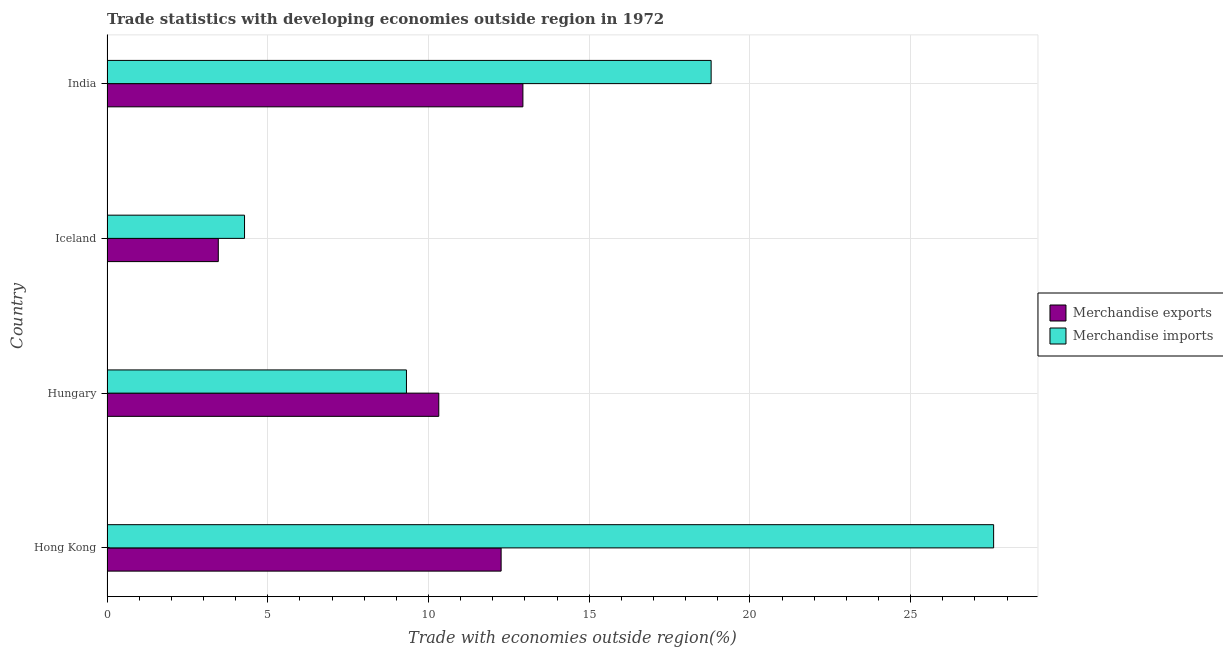How many groups of bars are there?
Keep it short and to the point. 4. Are the number of bars per tick equal to the number of legend labels?
Your answer should be very brief. Yes. Are the number of bars on each tick of the Y-axis equal?
Your response must be concise. Yes. How many bars are there on the 1st tick from the bottom?
Keep it short and to the point. 2. What is the label of the 1st group of bars from the top?
Your response must be concise. India. What is the merchandise exports in India?
Ensure brevity in your answer.  12.94. Across all countries, what is the maximum merchandise exports?
Make the answer very short. 12.94. Across all countries, what is the minimum merchandise imports?
Give a very brief answer. 4.28. In which country was the merchandise imports maximum?
Your answer should be very brief. Hong Kong. What is the total merchandise imports in the graph?
Give a very brief answer. 59.97. What is the difference between the merchandise exports in Hungary and that in Iceland?
Offer a terse response. 6.86. What is the difference between the merchandise exports in Hong Kong and the merchandise imports in India?
Keep it short and to the point. -6.53. What is the average merchandise exports per country?
Keep it short and to the point. 9.74. What is the difference between the merchandise imports and merchandise exports in India?
Give a very brief answer. 5.86. What is the ratio of the merchandise exports in Hong Kong to that in Hungary?
Give a very brief answer. 1.19. What is the difference between the highest and the second highest merchandise exports?
Offer a terse response. 0.68. What is the difference between the highest and the lowest merchandise exports?
Give a very brief answer. 9.48. How many bars are there?
Ensure brevity in your answer.  8. Are all the bars in the graph horizontal?
Provide a succinct answer. Yes. How many countries are there in the graph?
Ensure brevity in your answer.  4. Are the values on the major ticks of X-axis written in scientific E-notation?
Provide a short and direct response. No. Where does the legend appear in the graph?
Give a very brief answer. Center right. How many legend labels are there?
Your response must be concise. 2. How are the legend labels stacked?
Your response must be concise. Vertical. What is the title of the graph?
Your answer should be compact. Trade statistics with developing economies outside region in 1972. Does "Male entrants" appear as one of the legend labels in the graph?
Provide a succinct answer. No. What is the label or title of the X-axis?
Offer a very short reply. Trade with economies outside region(%). What is the Trade with economies outside region(%) of Merchandise exports in Hong Kong?
Make the answer very short. 12.26. What is the Trade with economies outside region(%) in Merchandise imports in Hong Kong?
Keep it short and to the point. 27.58. What is the Trade with economies outside region(%) in Merchandise exports in Hungary?
Provide a succinct answer. 10.32. What is the Trade with economies outside region(%) in Merchandise imports in Hungary?
Give a very brief answer. 9.31. What is the Trade with economies outside region(%) in Merchandise exports in Iceland?
Offer a terse response. 3.46. What is the Trade with economies outside region(%) in Merchandise imports in Iceland?
Your answer should be compact. 4.28. What is the Trade with economies outside region(%) of Merchandise exports in India?
Provide a succinct answer. 12.94. What is the Trade with economies outside region(%) of Merchandise imports in India?
Provide a succinct answer. 18.79. Across all countries, what is the maximum Trade with economies outside region(%) in Merchandise exports?
Ensure brevity in your answer.  12.94. Across all countries, what is the maximum Trade with economies outside region(%) in Merchandise imports?
Provide a short and direct response. 27.58. Across all countries, what is the minimum Trade with economies outside region(%) of Merchandise exports?
Offer a terse response. 3.46. Across all countries, what is the minimum Trade with economies outside region(%) in Merchandise imports?
Ensure brevity in your answer.  4.28. What is the total Trade with economies outside region(%) of Merchandise exports in the graph?
Your answer should be very brief. 38.98. What is the total Trade with economies outside region(%) in Merchandise imports in the graph?
Provide a succinct answer. 59.97. What is the difference between the Trade with economies outside region(%) of Merchandise exports in Hong Kong and that in Hungary?
Your answer should be very brief. 1.94. What is the difference between the Trade with economies outside region(%) in Merchandise imports in Hong Kong and that in Hungary?
Provide a succinct answer. 18.27. What is the difference between the Trade with economies outside region(%) in Merchandise exports in Hong Kong and that in Iceland?
Offer a very short reply. 8.8. What is the difference between the Trade with economies outside region(%) of Merchandise imports in Hong Kong and that in Iceland?
Keep it short and to the point. 23.3. What is the difference between the Trade with economies outside region(%) of Merchandise exports in Hong Kong and that in India?
Ensure brevity in your answer.  -0.68. What is the difference between the Trade with economies outside region(%) of Merchandise imports in Hong Kong and that in India?
Give a very brief answer. 8.79. What is the difference between the Trade with economies outside region(%) of Merchandise exports in Hungary and that in Iceland?
Your response must be concise. 6.86. What is the difference between the Trade with economies outside region(%) of Merchandise imports in Hungary and that in Iceland?
Make the answer very short. 5.04. What is the difference between the Trade with economies outside region(%) of Merchandise exports in Hungary and that in India?
Your answer should be compact. -2.62. What is the difference between the Trade with economies outside region(%) of Merchandise imports in Hungary and that in India?
Provide a succinct answer. -9.48. What is the difference between the Trade with economies outside region(%) in Merchandise exports in Iceland and that in India?
Provide a succinct answer. -9.48. What is the difference between the Trade with economies outside region(%) in Merchandise imports in Iceland and that in India?
Give a very brief answer. -14.51. What is the difference between the Trade with economies outside region(%) of Merchandise exports in Hong Kong and the Trade with economies outside region(%) of Merchandise imports in Hungary?
Keep it short and to the point. 2.94. What is the difference between the Trade with economies outside region(%) in Merchandise exports in Hong Kong and the Trade with economies outside region(%) in Merchandise imports in Iceland?
Your response must be concise. 7.98. What is the difference between the Trade with economies outside region(%) in Merchandise exports in Hong Kong and the Trade with economies outside region(%) in Merchandise imports in India?
Your answer should be compact. -6.53. What is the difference between the Trade with economies outside region(%) of Merchandise exports in Hungary and the Trade with economies outside region(%) of Merchandise imports in Iceland?
Make the answer very short. 6.04. What is the difference between the Trade with economies outside region(%) in Merchandise exports in Hungary and the Trade with economies outside region(%) in Merchandise imports in India?
Provide a short and direct response. -8.47. What is the difference between the Trade with economies outside region(%) in Merchandise exports in Iceland and the Trade with economies outside region(%) in Merchandise imports in India?
Provide a succinct answer. -15.33. What is the average Trade with economies outside region(%) in Merchandise exports per country?
Keep it short and to the point. 9.74. What is the average Trade with economies outside region(%) of Merchandise imports per country?
Provide a succinct answer. 14.99. What is the difference between the Trade with economies outside region(%) of Merchandise exports and Trade with economies outside region(%) of Merchandise imports in Hong Kong?
Give a very brief answer. -15.32. What is the difference between the Trade with economies outside region(%) in Merchandise exports and Trade with economies outside region(%) in Merchandise imports in Hungary?
Give a very brief answer. 1.01. What is the difference between the Trade with economies outside region(%) in Merchandise exports and Trade with economies outside region(%) in Merchandise imports in Iceland?
Your answer should be compact. -0.82. What is the difference between the Trade with economies outside region(%) in Merchandise exports and Trade with economies outside region(%) in Merchandise imports in India?
Give a very brief answer. -5.85. What is the ratio of the Trade with economies outside region(%) in Merchandise exports in Hong Kong to that in Hungary?
Make the answer very short. 1.19. What is the ratio of the Trade with economies outside region(%) of Merchandise imports in Hong Kong to that in Hungary?
Keep it short and to the point. 2.96. What is the ratio of the Trade with economies outside region(%) in Merchandise exports in Hong Kong to that in Iceland?
Provide a short and direct response. 3.54. What is the ratio of the Trade with economies outside region(%) in Merchandise imports in Hong Kong to that in Iceland?
Offer a terse response. 6.45. What is the ratio of the Trade with economies outside region(%) of Merchandise exports in Hong Kong to that in India?
Give a very brief answer. 0.95. What is the ratio of the Trade with economies outside region(%) in Merchandise imports in Hong Kong to that in India?
Make the answer very short. 1.47. What is the ratio of the Trade with economies outside region(%) of Merchandise exports in Hungary to that in Iceland?
Your answer should be very brief. 2.98. What is the ratio of the Trade with economies outside region(%) in Merchandise imports in Hungary to that in Iceland?
Provide a succinct answer. 2.18. What is the ratio of the Trade with economies outside region(%) in Merchandise exports in Hungary to that in India?
Your answer should be very brief. 0.8. What is the ratio of the Trade with economies outside region(%) of Merchandise imports in Hungary to that in India?
Make the answer very short. 0.5. What is the ratio of the Trade with economies outside region(%) in Merchandise exports in Iceland to that in India?
Your response must be concise. 0.27. What is the ratio of the Trade with economies outside region(%) of Merchandise imports in Iceland to that in India?
Offer a terse response. 0.23. What is the difference between the highest and the second highest Trade with economies outside region(%) in Merchandise exports?
Offer a terse response. 0.68. What is the difference between the highest and the second highest Trade with economies outside region(%) in Merchandise imports?
Your response must be concise. 8.79. What is the difference between the highest and the lowest Trade with economies outside region(%) in Merchandise exports?
Offer a terse response. 9.48. What is the difference between the highest and the lowest Trade with economies outside region(%) of Merchandise imports?
Keep it short and to the point. 23.3. 